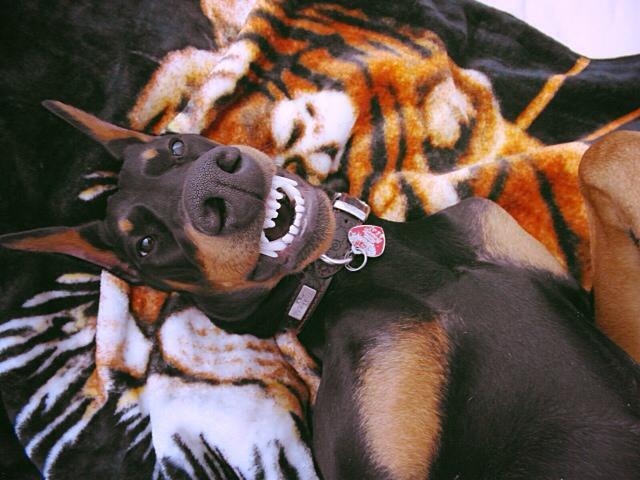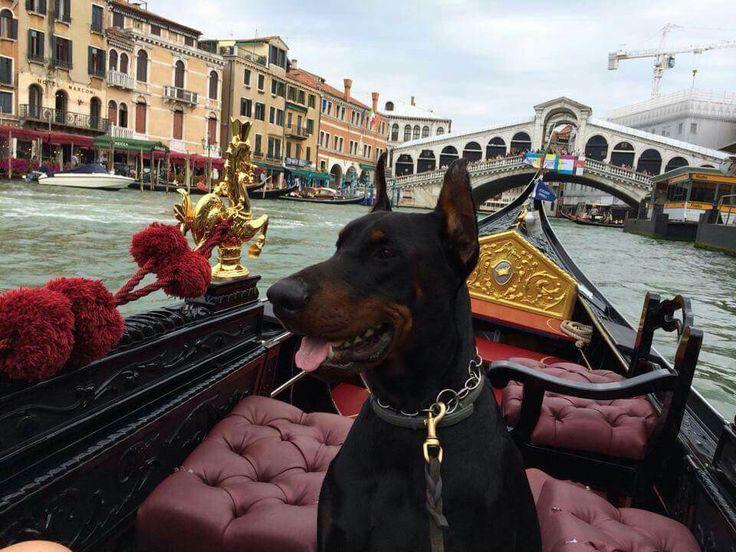The first image is the image on the left, the second image is the image on the right. For the images displayed, is the sentence "There are three dogs sitting down." factually correct? Answer yes or no. No. The first image is the image on the left, the second image is the image on the right. Assess this claim about the two images: "The right image contains exactly three doberman dogs with erect pointy ears wearing leashes and collars.". Correct or not? Answer yes or no. No. 